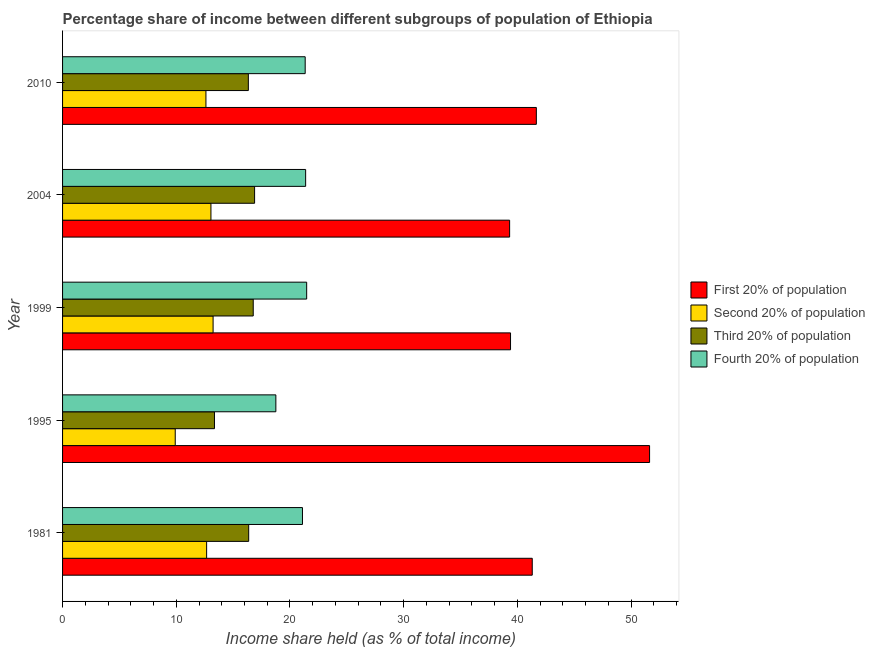Are the number of bars per tick equal to the number of legend labels?
Keep it short and to the point. Yes. How many bars are there on the 3rd tick from the top?
Keep it short and to the point. 4. How many bars are there on the 1st tick from the bottom?
Offer a terse response. 4. What is the share of the income held by third 20% of the population in 1995?
Offer a very short reply. 13.36. Across all years, what is the maximum share of the income held by fourth 20% of the population?
Ensure brevity in your answer.  21.47. Across all years, what is the minimum share of the income held by third 20% of the population?
Offer a terse response. 13.36. In which year was the share of the income held by second 20% of the population maximum?
Keep it short and to the point. 1999. In which year was the share of the income held by third 20% of the population minimum?
Provide a succinct answer. 1995. What is the total share of the income held by first 20% of the population in the graph?
Your answer should be compact. 213.33. What is the difference between the share of the income held by third 20% of the population in 1995 and that in 1999?
Offer a terse response. -3.41. What is the difference between the share of the income held by second 20% of the population in 2010 and the share of the income held by third 20% of the population in 1999?
Make the answer very short. -4.16. What is the average share of the income held by first 20% of the population per year?
Provide a short and direct response. 42.67. In the year 1981, what is the difference between the share of the income held by second 20% of the population and share of the income held by fourth 20% of the population?
Offer a very short reply. -8.43. In how many years, is the share of the income held by third 20% of the population greater than 46 %?
Provide a short and direct response. 0. Is the share of the income held by fourth 20% of the population in 1981 less than that in 2010?
Your answer should be very brief. Yes. What is the difference between the highest and the second highest share of the income held by second 20% of the population?
Your response must be concise. 0.19. What is the difference between the highest and the lowest share of the income held by second 20% of the population?
Ensure brevity in your answer.  3.33. What does the 2nd bar from the top in 1981 represents?
Your answer should be compact. Third 20% of population. What does the 4th bar from the bottom in 2004 represents?
Provide a short and direct response. Fourth 20% of population. Is it the case that in every year, the sum of the share of the income held by first 20% of the population and share of the income held by second 20% of the population is greater than the share of the income held by third 20% of the population?
Offer a terse response. Yes. Are all the bars in the graph horizontal?
Your answer should be very brief. Yes. Are the values on the major ticks of X-axis written in scientific E-notation?
Keep it short and to the point. No. Where does the legend appear in the graph?
Provide a succinct answer. Center right. How are the legend labels stacked?
Provide a short and direct response. Vertical. What is the title of the graph?
Your response must be concise. Percentage share of income between different subgroups of population of Ethiopia. What is the label or title of the X-axis?
Offer a very short reply. Income share held (as % of total income). What is the label or title of the Y-axis?
Give a very brief answer. Year. What is the Income share held (as % of total income) in First 20% of population in 1981?
Make the answer very short. 41.31. What is the Income share held (as % of total income) in Second 20% of population in 1981?
Offer a very short reply. 12.67. What is the Income share held (as % of total income) in Third 20% of population in 1981?
Offer a terse response. 16.37. What is the Income share held (as % of total income) in Fourth 20% of population in 1981?
Give a very brief answer. 21.1. What is the Income share held (as % of total income) in First 20% of population in 1995?
Keep it short and to the point. 51.63. What is the Income share held (as % of total income) of Second 20% of population in 1995?
Your answer should be compact. 9.91. What is the Income share held (as % of total income) in Third 20% of population in 1995?
Give a very brief answer. 13.36. What is the Income share held (as % of total income) of Fourth 20% of population in 1995?
Your answer should be compact. 18.76. What is the Income share held (as % of total income) in First 20% of population in 1999?
Keep it short and to the point. 39.4. What is the Income share held (as % of total income) in Second 20% of population in 1999?
Your response must be concise. 13.24. What is the Income share held (as % of total income) of Third 20% of population in 1999?
Give a very brief answer. 16.77. What is the Income share held (as % of total income) in Fourth 20% of population in 1999?
Your response must be concise. 21.47. What is the Income share held (as % of total income) of First 20% of population in 2004?
Keep it short and to the point. 39.32. What is the Income share held (as % of total income) of Second 20% of population in 2004?
Give a very brief answer. 13.05. What is the Income share held (as % of total income) in Third 20% of population in 2004?
Your answer should be very brief. 16.89. What is the Income share held (as % of total income) of Fourth 20% of population in 2004?
Offer a terse response. 21.38. What is the Income share held (as % of total income) in First 20% of population in 2010?
Your response must be concise. 41.67. What is the Income share held (as % of total income) of Second 20% of population in 2010?
Your answer should be very brief. 12.61. What is the Income share held (as % of total income) of Third 20% of population in 2010?
Your response must be concise. 16.34. What is the Income share held (as % of total income) in Fourth 20% of population in 2010?
Give a very brief answer. 21.34. Across all years, what is the maximum Income share held (as % of total income) in First 20% of population?
Offer a very short reply. 51.63. Across all years, what is the maximum Income share held (as % of total income) of Second 20% of population?
Your answer should be very brief. 13.24. Across all years, what is the maximum Income share held (as % of total income) of Third 20% of population?
Provide a short and direct response. 16.89. Across all years, what is the maximum Income share held (as % of total income) of Fourth 20% of population?
Offer a terse response. 21.47. Across all years, what is the minimum Income share held (as % of total income) in First 20% of population?
Make the answer very short. 39.32. Across all years, what is the minimum Income share held (as % of total income) in Second 20% of population?
Your answer should be compact. 9.91. Across all years, what is the minimum Income share held (as % of total income) of Third 20% of population?
Ensure brevity in your answer.  13.36. Across all years, what is the minimum Income share held (as % of total income) of Fourth 20% of population?
Offer a very short reply. 18.76. What is the total Income share held (as % of total income) of First 20% of population in the graph?
Your answer should be very brief. 213.33. What is the total Income share held (as % of total income) of Second 20% of population in the graph?
Your answer should be very brief. 61.48. What is the total Income share held (as % of total income) in Third 20% of population in the graph?
Your response must be concise. 79.73. What is the total Income share held (as % of total income) in Fourth 20% of population in the graph?
Make the answer very short. 104.05. What is the difference between the Income share held (as % of total income) in First 20% of population in 1981 and that in 1995?
Make the answer very short. -10.32. What is the difference between the Income share held (as % of total income) in Second 20% of population in 1981 and that in 1995?
Ensure brevity in your answer.  2.76. What is the difference between the Income share held (as % of total income) in Third 20% of population in 1981 and that in 1995?
Your answer should be compact. 3.01. What is the difference between the Income share held (as % of total income) of Fourth 20% of population in 1981 and that in 1995?
Make the answer very short. 2.34. What is the difference between the Income share held (as % of total income) in First 20% of population in 1981 and that in 1999?
Offer a very short reply. 1.91. What is the difference between the Income share held (as % of total income) in Second 20% of population in 1981 and that in 1999?
Give a very brief answer. -0.57. What is the difference between the Income share held (as % of total income) in Third 20% of population in 1981 and that in 1999?
Your response must be concise. -0.4. What is the difference between the Income share held (as % of total income) of Fourth 20% of population in 1981 and that in 1999?
Provide a short and direct response. -0.37. What is the difference between the Income share held (as % of total income) of First 20% of population in 1981 and that in 2004?
Give a very brief answer. 1.99. What is the difference between the Income share held (as % of total income) in Second 20% of population in 1981 and that in 2004?
Your answer should be very brief. -0.38. What is the difference between the Income share held (as % of total income) in Third 20% of population in 1981 and that in 2004?
Give a very brief answer. -0.52. What is the difference between the Income share held (as % of total income) in Fourth 20% of population in 1981 and that in 2004?
Your response must be concise. -0.28. What is the difference between the Income share held (as % of total income) in First 20% of population in 1981 and that in 2010?
Your answer should be very brief. -0.36. What is the difference between the Income share held (as % of total income) in Second 20% of population in 1981 and that in 2010?
Provide a short and direct response. 0.06. What is the difference between the Income share held (as % of total income) of Third 20% of population in 1981 and that in 2010?
Keep it short and to the point. 0.03. What is the difference between the Income share held (as % of total income) in Fourth 20% of population in 1981 and that in 2010?
Your response must be concise. -0.24. What is the difference between the Income share held (as % of total income) in First 20% of population in 1995 and that in 1999?
Offer a terse response. 12.23. What is the difference between the Income share held (as % of total income) in Second 20% of population in 1995 and that in 1999?
Your answer should be very brief. -3.33. What is the difference between the Income share held (as % of total income) of Third 20% of population in 1995 and that in 1999?
Your response must be concise. -3.41. What is the difference between the Income share held (as % of total income) of Fourth 20% of population in 1995 and that in 1999?
Offer a terse response. -2.71. What is the difference between the Income share held (as % of total income) in First 20% of population in 1995 and that in 2004?
Your answer should be compact. 12.31. What is the difference between the Income share held (as % of total income) of Second 20% of population in 1995 and that in 2004?
Provide a succinct answer. -3.14. What is the difference between the Income share held (as % of total income) of Third 20% of population in 1995 and that in 2004?
Your answer should be compact. -3.53. What is the difference between the Income share held (as % of total income) in Fourth 20% of population in 1995 and that in 2004?
Provide a succinct answer. -2.62. What is the difference between the Income share held (as % of total income) of First 20% of population in 1995 and that in 2010?
Provide a short and direct response. 9.96. What is the difference between the Income share held (as % of total income) in Second 20% of population in 1995 and that in 2010?
Offer a very short reply. -2.7. What is the difference between the Income share held (as % of total income) in Third 20% of population in 1995 and that in 2010?
Offer a terse response. -2.98. What is the difference between the Income share held (as % of total income) in Fourth 20% of population in 1995 and that in 2010?
Make the answer very short. -2.58. What is the difference between the Income share held (as % of total income) of First 20% of population in 1999 and that in 2004?
Your answer should be compact. 0.08. What is the difference between the Income share held (as % of total income) in Second 20% of population in 1999 and that in 2004?
Provide a short and direct response. 0.19. What is the difference between the Income share held (as % of total income) in Third 20% of population in 1999 and that in 2004?
Make the answer very short. -0.12. What is the difference between the Income share held (as % of total income) of Fourth 20% of population in 1999 and that in 2004?
Your answer should be compact. 0.09. What is the difference between the Income share held (as % of total income) of First 20% of population in 1999 and that in 2010?
Ensure brevity in your answer.  -2.27. What is the difference between the Income share held (as % of total income) of Second 20% of population in 1999 and that in 2010?
Provide a succinct answer. 0.63. What is the difference between the Income share held (as % of total income) of Third 20% of population in 1999 and that in 2010?
Offer a terse response. 0.43. What is the difference between the Income share held (as % of total income) in Fourth 20% of population in 1999 and that in 2010?
Give a very brief answer. 0.13. What is the difference between the Income share held (as % of total income) in First 20% of population in 2004 and that in 2010?
Your answer should be very brief. -2.35. What is the difference between the Income share held (as % of total income) of Second 20% of population in 2004 and that in 2010?
Provide a short and direct response. 0.44. What is the difference between the Income share held (as % of total income) of Third 20% of population in 2004 and that in 2010?
Make the answer very short. 0.55. What is the difference between the Income share held (as % of total income) of First 20% of population in 1981 and the Income share held (as % of total income) of Second 20% of population in 1995?
Ensure brevity in your answer.  31.4. What is the difference between the Income share held (as % of total income) in First 20% of population in 1981 and the Income share held (as % of total income) in Third 20% of population in 1995?
Ensure brevity in your answer.  27.95. What is the difference between the Income share held (as % of total income) in First 20% of population in 1981 and the Income share held (as % of total income) in Fourth 20% of population in 1995?
Ensure brevity in your answer.  22.55. What is the difference between the Income share held (as % of total income) in Second 20% of population in 1981 and the Income share held (as % of total income) in Third 20% of population in 1995?
Give a very brief answer. -0.69. What is the difference between the Income share held (as % of total income) of Second 20% of population in 1981 and the Income share held (as % of total income) of Fourth 20% of population in 1995?
Offer a terse response. -6.09. What is the difference between the Income share held (as % of total income) in Third 20% of population in 1981 and the Income share held (as % of total income) in Fourth 20% of population in 1995?
Make the answer very short. -2.39. What is the difference between the Income share held (as % of total income) in First 20% of population in 1981 and the Income share held (as % of total income) in Second 20% of population in 1999?
Your answer should be very brief. 28.07. What is the difference between the Income share held (as % of total income) of First 20% of population in 1981 and the Income share held (as % of total income) of Third 20% of population in 1999?
Keep it short and to the point. 24.54. What is the difference between the Income share held (as % of total income) in First 20% of population in 1981 and the Income share held (as % of total income) in Fourth 20% of population in 1999?
Provide a short and direct response. 19.84. What is the difference between the Income share held (as % of total income) of Third 20% of population in 1981 and the Income share held (as % of total income) of Fourth 20% of population in 1999?
Give a very brief answer. -5.1. What is the difference between the Income share held (as % of total income) in First 20% of population in 1981 and the Income share held (as % of total income) in Second 20% of population in 2004?
Give a very brief answer. 28.26. What is the difference between the Income share held (as % of total income) of First 20% of population in 1981 and the Income share held (as % of total income) of Third 20% of population in 2004?
Offer a terse response. 24.42. What is the difference between the Income share held (as % of total income) in First 20% of population in 1981 and the Income share held (as % of total income) in Fourth 20% of population in 2004?
Provide a succinct answer. 19.93. What is the difference between the Income share held (as % of total income) of Second 20% of population in 1981 and the Income share held (as % of total income) of Third 20% of population in 2004?
Your answer should be very brief. -4.22. What is the difference between the Income share held (as % of total income) in Second 20% of population in 1981 and the Income share held (as % of total income) in Fourth 20% of population in 2004?
Provide a short and direct response. -8.71. What is the difference between the Income share held (as % of total income) of Third 20% of population in 1981 and the Income share held (as % of total income) of Fourth 20% of population in 2004?
Your answer should be compact. -5.01. What is the difference between the Income share held (as % of total income) of First 20% of population in 1981 and the Income share held (as % of total income) of Second 20% of population in 2010?
Ensure brevity in your answer.  28.7. What is the difference between the Income share held (as % of total income) in First 20% of population in 1981 and the Income share held (as % of total income) in Third 20% of population in 2010?
Offer a very short reply. 24.97. What is the difference between the Income share held (as % of total income) of First 20% of population in 1981 and the Income share held (as % of total income) of Fourth 20% of population in 2010?
Provide a short and direct response. 19.97. What is the difference between the Income share held (as % of total income) of Second 20% of population in 1981 and the Income share held (as % of total income) of Third 20% of population in 2010?
Provide a succinct answer. -3.67. What is the difference between the Income share held (as % of total income) of Second 20% of population in 1981 and the Income share held (as % of total income) of Fourth 20% of population in 2010?
Make the answer very short. -8.67. What is the difference between the Income share held (as % of total income) in Third 20% of population in 1981 and the Income share held (as % of total income) in Fourth 20% of population in 2010?
Your answer should be compact. -4.97. What is the difference between the Income share held (as % of total income) of First 20% of population in 1995 and the Income share held (as % of total income) of Second 20% of population in 1999?
Keep it short and to the point. 38.39. What is the difference between the Income share held (as % of total income) in First 20% of population in 1995 and the Income share held (as % of total income) in Third 20% of population in 1999?
Make the answer very short. 34.86. What is the difference between the Income share held (as % of total income) of First 20% of population in 1995 and the Income share held (as % of total income) of Fourth 20% of population in 1999?
Provide a succinct answer. 30.16. What is the difference between the Income share held (as % of total income) of Second 20% of population in 1995 and the Income share held (as % of total income) of Third 20% of population in 1999?
Your answer should be very brief. -6.86. What is the difference between the Income share held (as % of total income) of Second 20% of population in 1995 and the Income share held (as % of total income) of Fourth 20% of population in 1999?
Ensure brevity in your answer.  -11.56. What is the difference between the Income share held (as % of total income) of Third 20% of population in 1995 and the Income share held (as % of total income) of Fourth 20% of population in 1999?
Your answer should be compact. -8.11. What is the difference between the Income share held (as % of total income) of First 20% of population in 1995 and the Income share held (as % of total income) of Second 20% of population in 2004?
Ensure brevity in your answer.  38.58. What is the difference between the Income share held (as % of total income) in First 20% of population in 1995 and the Income share held (as % of total income) in Third 20% of population in 2004?
Offer a terse response. 34.74. What is the difference between the Income share held (as % of total income) of First 20% of population in 1995 and the Income share held (as % of total income) of Fourth 20% of population in 2004?
Ensure brevity in your answer.  30.25. What is the difference between the Income share held (as % of total income) in Second 20% of population in 1995 and the Income share held (as % of total income) in Third 20% of population in 2004?
Offer a very short reply. -6.98. What is the difference between the Income share held (as % of total income) in Second 20% of population in 1995 and the Income share held (as % of total income) in Fourth 20% of population in 2004?
Provide a succinct answer. -11.47. What is the difference between the Income share held (as % of total income) of Third 20% of population in 1995 and the Income share held (as % of total income) of Fourth 20% of population in 2004?
Provide a succinct answer. -8.02. What is the difference between the Income share held (as % of total income) in First 20% of population in 1995 and the Income share held (as % of total income) in Second 20% of population in 2010?
Offer a very short reply. 39.02. What is the difference between the Income share held (as % of total income) of First 20% of population in 1995 and the Income share held (as % of total income) of Third 20% of population in 2010?
Provide a short and direct response. 35.29. What is the difference between the Income share held (as % of total income) in First 20% of population in 1995 and the Income share held (as % of total income) in Fourth 20% of population in 2010?
Your answer should be compact. 30.29. What is the difference between the Income share held (as % of total income) in Second 20% of population in 1995 and the Income share held (as % of total income) in Third 20% of population in 2010?
Your answer should be compact. -6.43. What is the difference between the Income share held (as % of total income) in Second 20% of population in 1995 and the Income share held (as % of total income) in Fourth 20% of population in 2010?
Provide a succinct answer. -11.43. What is the difference between the Income share held (as % of total income) in Third 20% of population in 1995 and the Income share held (as % of total income) in Fourth 20% of population in 2010?
Make the answer very short. -7.98. What is the difference between the Income share held (as % of total income) in First 20% of population in 1999 and the Income share held (as % of total income) in Second 20% of population in 2004?
Your answer should be very brief. 26.35. What is the difference between the Income share held (as % of total income) in First 20% of population in 1999 and the Income share held (as % of total income) in Third 20% of population in 2004?
Keep it short and to the point. 22.51. What is the difference between the Income share held (as % of total income) in First 20% of population in 1999 and the Income share held (as % of total income) in Fourth 20% of population in 2004?
Your answer should be very brief. 18.02. What is the difference between the Income share held (as % of total income) in Second 20% of population in 1999 and the Income share held (as % of total income) in Third 20% of population in 2004?
Provide a succinct answer. -3.65. What is the difference between the Income share held (as % of total income) of Second 20% of population in 1999 and the Income share held (as % of total income) of Fourth 20% of population in 2004?
Ensure brevity in your answer.  -8.14. What is the difference between the Income share held (as % of total income) in Third 20% of population in 1999 and the Income share held (as % of total income) in Fourth 20% of population in 2004?
Make the answer very short. -4.61. What is the difference between the Income share held (as % of total income) in First 20% of population in 1999 and the Income share held (as % of total income) in Second 20% of population in 2010?
Your answer should be compact. 26.79. What is the difference between the Income share held (as % of total income) in First 20% of population in 1999 and the Income share held (as % of total income) in Third 20% of population in 2010?
Make the answer very short. 23.06. What is the difference between the Income share held (as % of total income) of First 20% of population in 1999 and the Income share held (as % of total income) of Fourth 20% of population in 2010?
Your response must be concise. 18.06. What is the difference between the Income share held (as % of total income) in Third 20% of population in 1999 and the Income share held (as % of total income) in Fourth 20% of population in 2010?
Your response must be concise. -4.57. What is the difference between the Income share held (as % of total income) in First 20% of population in 2004 and the Income share held (as % of total income) in Second 20% of population in 2010?
Provide a short and direct response. 26.71. What is the difference between the Income share held (as % of total income) in First 20% of population in 2004 and the Income share held (as % of total income) in Third 20% of population in 2010?
Give a very brief answer. 22.98. What is the difference between the Income share held (as % of total income) of First 20% of population in 2004 and the Income share held (as % of total income) of Fourth 20% of population in 2010?
Ensure brevity in your answer.  17.98. What is the difference between the Income share held (as % of total income) of Second 20% of population in 2004 and the Income share held (as % of total income) of Third 20% of population in 2010?
Keep it short and to the point. -3.29. What is the difference between the Income share held (as % of total income) in Second 20% of population in 2004 and the Income share held (as % of total income) in Fourth 20% of population in 2010?
Keep it short and to the point. -8.29. What is the difference between the Income share held (as % of total income) of Third 20% of population in 2004 and the Income share held (as % of total income) of Fourth 20% of population in 2010?
Your response must be concise. -4.45. What is the average Income share held (as % of total income) of First 20% of population per year?
Make the answer very short. 42.67. What is the average Income share held (as % of total income) of Second 20% of population per year?
Give a very brief answer. 12.3. What is the average Income share held (as % of total income) in Third 20% of population per year?
Provide a short and direct response. 15.95. What is the average Income share held (as % of total income) in Fourth 20% of population per year?
Keep it short and to the point. 20.81. In the year 1981, what is the difference between the Income share held (as % of total income) of First 20% of population and Income share held (as % of total income) of Second 20% of population?
Your response must be concise. 28.64. In the year 1981, what is the difference between the Income share held (as % of total income) in First 20% of population and Income share held (as % of total income) in Third 20% of population?
Make the answer very short. 24.94. In the year 1981, what is the difference between the Income share held (as % of total income) of First 20% of population and Income share held (as % of total income) of Fourth 20% of population?
Your response must be concise. 20.21. In the year 1981, what is the difference between the Income share held (as % of total income) in Second 20% of population and Income share held (as % of total income) in Fourth 20% of population?
Provide a succinct answer. -8.43. In the year 1981, what is the difference between the Income share held (as % of total income) in Third 20% of population and Income share held (as % of total income) in Fourth 20% of population?
Give a very brief answer. -4.73. In the year 1995, what is the difference between the Income share held (as % of total income) in First 20% of population and Income share held (as % of total income) in Second 20% of population?
Offer a very short reply. 41.72. In the year 1995, what is the difference between the Income share held (as % of total income) of First 20% of population and Income share held (as % of total income) of Third 20% of population?
Your answer should be very brief. 38.27. In the year 1995, what is the difference between the Income share held (as % of total income) in First 20% of population and Income share held (as % of total income) in Fourth 20% of population?
Provide a short and direct response. 32.87. In the year 1995, what is the difference between the Income share held (as % of total income) in Second 20% of population and Income share held (as % of total income) in Third 20% of population?
Your answer should be very brief. -3.45. In the year 1995, what is the difference between the Income share held (as % of total income) of Second 20% of population and Income share held (as % of total income) of Fourth 20% of population?
Provide a succinct answer. -8.85. In the year 1999, what is the difference between the Income share held (as % of total income) of First 20% of population and Income share held (as % of total income) of Second 20% of population?
Your answer should be very brief. 26.16. In the year 1999, what is the difference between the Income share held (as % of total income) of First 20% of population and Income share held (as % of total income) of Third 20% of population?
Your response must be concise. 22.63. In the year 1999, what is the difference between the Income share held (as % of total income) in First 20% of population and Income share held (as % of total income) in Fourth 20% of population?
Offer a terse response. 17.93. In the year 1999, what is the difference between the Income share held (as % of total income) in Second 20% of population and Income share held (as % of total income) in Third 20% of population?
Ensure brevity in your answer.  -3.53. In the year 1999, what is the difference between the Income share held (as % of total income) in Second 20% of population and Income share held (as % of total income) in Fourth 20% of population?
Ensure brevity in your answer.  -8.23. In the year 2004, what is the difference between the Income share held (as % of total income) in First 20% of population and Income share held (as % of total income) in Second 20% of population?
Make the answer very short. 26.27. In the year 2004, what is the difference between the Income share held (as % of total income) of First 20% of population and Income share held (as % of total income) of Third 20% of population?
Ensure brevity in your answer.  22.43. In the year 2004, what is the difference between the Income share held (as % of total income) of First 20% of population and Income share held (as % of total income) of Fourth 20% of population?
Give a very brief answer. 17.94. In the year 2004, what is the difference between the Income share held (as % of total income) in Second 20% of population and Income share held (as % of total income) in Third 20% of population?
Offer a terse response. -3.84. In the year 2004, what is the difference between the Income share held (as % of total income) of Second 20% of population and Income share held (as % of total income) of Fourth 20% of population?
Ensure brevity in your answer.  -8.33. In the year 2004, what is the difference between the Income share held (as % of total income) in Third 20% of population and Income share held (as % of total income) in Fourth 20% of population?
Provide a succinct answer. -4.49. In the year 2010, what is the difference between the Income share held (as % of total income) in First 20% of population and Income share held (as % of total income) in Second 20% of population?
Your answer should be compact. 29.06. In the year 2010, what is the difference between the Income share held (as % of total income) of First 20% of population and Income share held (as % of total income) of Third 20% of population?
Your answer should be very brief. 25.33. In the year 2010, what is the difference between the Income share held (as % of total income) of First 20% of population and Income share held (as % of total income) of Fourth 20% of population?
Ensure brevity in your answer.  20.33. In the year 2010, what is the difference between the Income share held (as % of total income) in Second 20% of population and Income share held (as % of total income) in Third 20% of population?
Your response must be concise. -3.73. In the year 2010, what is the difference between the Income share held (as % of total income) in Second 20% of population and Income share held (as % of total income) in Fourth 20% of population?
Your response must be concise. -8.73. What is the ratio of the Income share held (as % of total income) of First 20% of population in 1981 to that in 1995?
Provide a short and direct response. 0.8. What is the ratio of the Income share held (as % of total income) of Second 20% of population in 1981 to that in 1995?
Give a very brief answer. 1.28. What is the ratio of the Income share held (as % of total income) in Third 20% of population in 1981 to that in 1995?
Provide a short and direct response. 1.23. What is the ratio of the Income share held (as % of total income) in Fourth 20% of population in 1981 to that in 1995?
Your response must be concise. 1.12. What is the ratio of the Income share held (as % of total income) in First 20% of population in 1981 to that in 1999?
Provide a short and direct response. 1.05. What is the ratio of the Income share held (as % of total income) of Second 20% of population in 1981 to that in 1999?
Provide a short and direct response. 0.96. What is the ratio of the Income share held (as % of total income) in Third 20% of population in 1981 to that in 1999?
Keep it short and to the point. 0.98. What is the ratio of the Income share held (as % of total income) in Fourth 20% of population in 1981 to that in 1999?
Your response must be concise. 0.98. What is the ratio of the Income share held (as % of total income) in First 20% of population in 1981 to that in 2004?
Your response must be concise. 1.05. What is the ratio of the Income share held (as % of total income) of Second 20% of population in 1981 to that in 2004?
Provide a short and direct response. 0.97. What is the ratio of the Income share held (as % of total income) of Third 20% of population in 1981 to that in 2004?
Offer a terse response. 0.97. What is the ratio of the Income share held (as % of total income) in Fourth 20% of population in 1981 to that in 2004?
Your response must be concise. 0.99. What is the ratio of the Income share held (as % of total income) in Third 20% of population in 1981 to that in 2010?
Offer a terse response. 1. What is the ratio of the Income share held (as % of total income) of First 20% of population in 1995 to that in 1999?
Make the answer very short. 1.31. What is the ratio of the Income share held (as % of total income) of Second 20% of population in 1995 to that in 1999?
Give a very brief answer. 0.75. What is the ratio of the Income share held (as % of total income) of Third 20% of population in 1995 to that in 1999?
Your answer should be very brief. 0.8. What is the ratio of the Income share held (as % of total income) of Fourth 20% of population in 1995 to that in 1999?
Ensure brevity in your answer.  0.87. What is the ratio of the Income share held (as % of total income) of First 20% of population in 1995 to that in 2004?
Ensure brevity in your answer.  1.31. What is the ratio of the Income share held (as % of total income) in Second 20% of population in 1995 to that in 2004?
Offer a terse response. 0.76. What is the ratio of the Income share held (as % of total income) in Third 20% of population in 1995 to that in 2004?
Make the answer very short. 0.79. What is the ratio of the Income share held (as % of total income) in Fourth 20% of population in 1995 to that in 2004?
Provide a succinct answer. 0.88. What is the ratio of the Income share held (as % of total income) in First 20% of population in 1995 to that in 2010?
Provide a succinct answer. 1.24. What is the ratio of the Income share held (as % of total income) in Second 20% of population in 1995 to that in 2010?
Make the answer very short. 0.79. What is the ratio of the Income share held (as % of total income) in Third 20% of population in 1995 to that in 2010?
Offer a very short reply. 0.82. What is the ratio of the Income share held (as % of total income) in Fourth 20% of population in 1995 to that in 2010?
Your response must be concise. 0.88. What is the ratio of the Income share held (as % of total income) of First 20% of population in 1999 to that in 2004?
Your answer should be compact. 1. What is the ratio of the Income share held (as % of total income) of Second 20% of population in 1999 to that in 2004?
Your answer should be very brief. 1.01. What is the ratio of the Income share held (as % of total income) of Fourth 20% of population in 1999 to that in 2004?
Provide a short and direct response. 1. What is the ratio of the Income share held (as % of total income) of First 20% of population in 1999 to that in 2010?
Make the answer very short. 0.95. What is the ratio of the Income share held (as % of total income) in Third 20% of population in 1999 to that in 2010?
Your answer should be very brief. 1.03. What is the ratio of the Income share held (as % of total income) in First 20% of population in 2004 to that in 2010?
Ensure brevity in your answer.  0.94. What is the ratio of the Income share held (as % of total income) of Second 20% of population in 2004 to that in 2010?
Provide a short and direct response. 1.03. What is the ratio of the Income share held (as % of total income) of Third 20% of population in 2004 to that in 2010?
Keep it short and to the point. 1.03. What is the ratio of the Income share held (as % of total income) of Fourth 20% of population in 2004 to that in 2010?
Your answer should be very brief. 1. What is the difference between the highest and the second highest Income share held (as % of total income) in First 20% of population?
Offer a terse response. 9.96. What is the difference between the highest and the second highest Income share held (as % of total income) of Second 20% of population?
Offer a very short reply. 0.19. What is the difference between the highest and the second highest Income share held (as % of total income) in Third 20% of population?
Your answer should be very brief. 0.12. What is the difference between the highest and the second highest Income share held (as % of total income) in Fourth 20% of population?
Provide a short and direct response. 0.09. What is the difference between the highest and the lowest Income share held (as % of total income) in First 20% of population?
Ensure brevity in your answer.  12.31. What is the difference between the highest and the lowest Income share held (as % of total income) of Second 20% of population?
Your response must be concise. 3.33. What is the difference between the highest and the lowest Income share held (as % of total income) of Third 20% of population?
Offer a terse response. 3.53. What is the difference between the highest and the lowest Income share held (as % of total income) of Fourth 20% of population?
Give a very brief answer. 2.71. 